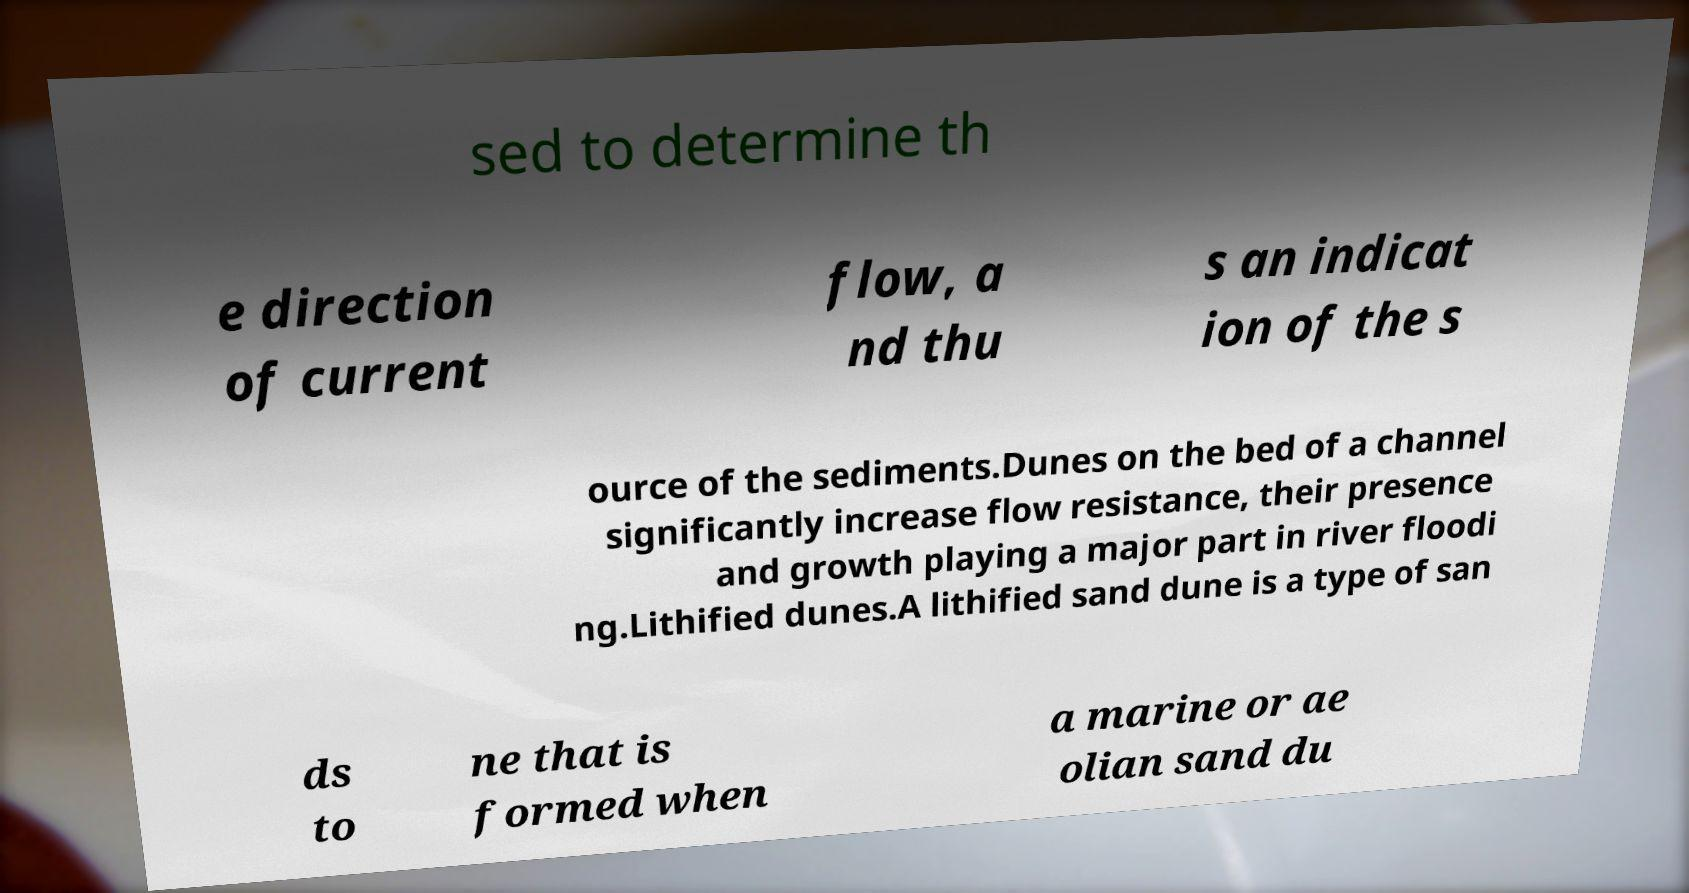Please read and relay the text visible in this image. What does it say? sed to determine th e direction of current flow, a nd thu s an indicat ion of the s ource of the sediments.Dunes on the bed of a channel significantly increase flow resistance, their presence and growth playing a major part in river floodi ng.Lithified dunes.A lithified sand dune is a type of san ds to ne that is formed when a marine or ae olian sand du 